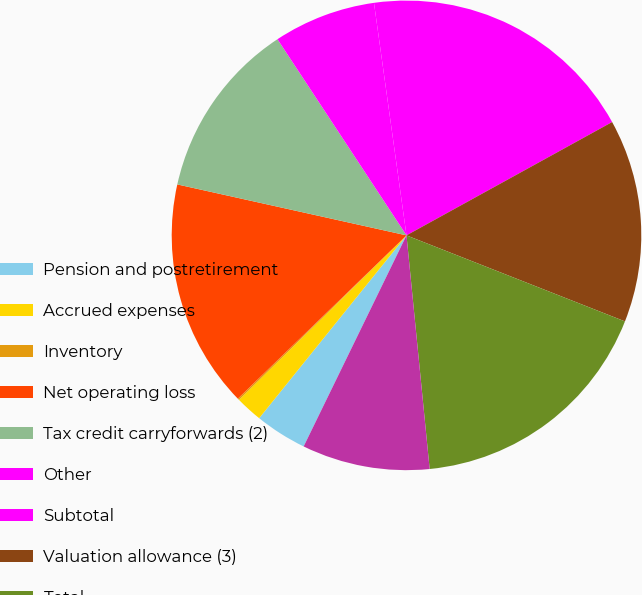Convert chart. <chart><loc_0><loc_0><loc_500><loc_500><pie_chart><fcel>Pension and postretirement<fcel>Accrued expenses<fcel>Inventory<fcel>Net operating loss<fcel>Tax credit carryforwards (2)<fcel>Other<fcel>Subtotal<fcel>Valuation allowance (3)<fcel>Total<fcel>Depreciation and amortization<nl><fcel>3.58%<fcel>1.85%<fcel>0.11%<fcel>15.73%<fcel>12.26%<fcel>7.05%<fcel>19.2%<fcel>13.99%<fcel>17.46%<fcel>8.79%<nl></chart> 